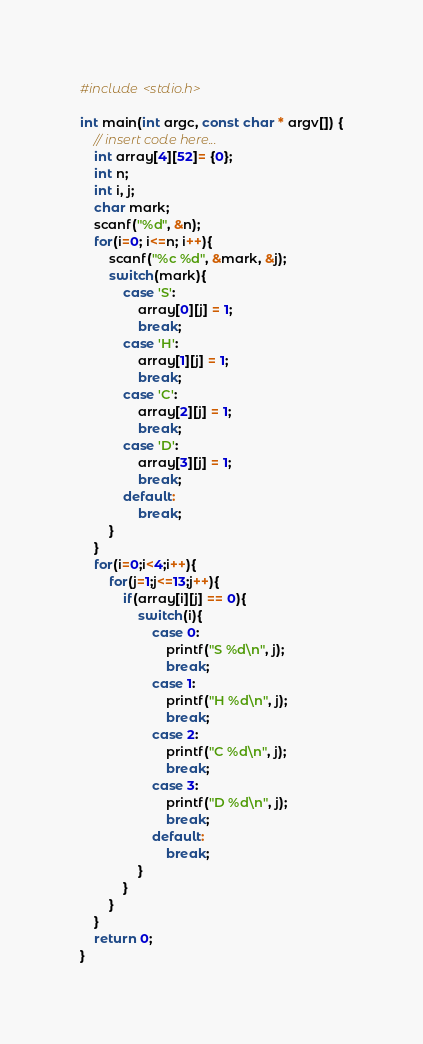Convert code to text. <code><loc_0><loc_0><loc_500><loc_500><_C_>#include <stdio.h>

int main(int argc, const char * argv[]) {
    // insert code here...
    int array[4][52]= {0};
    int n;
    int i, j;
    char mark;
    scanf("%d", &n);
    for(i=0; i<=n; i++){
        scanf("%c %d", &mark, &j);
        switch(mark){
            case 'S':
                array[0][j] = 1;
                break;
            case 'H':
                array[1][j] = 1;
                break;
            case 'C':
                array[2][j] = 1;
                break;
            case 'D':
                array[3][j] = 1;
                break;
            default:
                break;
        }
    }
    for(i=0;i<4;i++){
        for(j=1;j<=13;j++){
            if(array[i][j] == 0){
                switch(i){
                    case 0:
                        printf("S %d\n", j);
                        break;
                    case 1:
                        printf("H %d\n", j);
                        break;
                    case 2:
                        printf("C %d\n", j);
                        break;
                    case 3:
                        printf("D %d\n", j);
                        break;
                    default:
                        break;
                }
            }
        }
    }
    return 0;
}</code> 